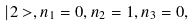Convert formula to latex. <formula><loc_0><loc_0><loc_500><loc_500>| 2 > , n _ { 1 } = 0 , n _ { 2 } = 1 , n _ { 3 } = 0 ,</formula> 